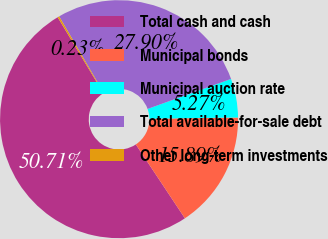Convert chart to OTSL. <chart><loc_0><loc_0><loc_500><loc_500><pie_chart><fcel>Total cash and cash<fcel>Municipal bonds<fcel>Municipal auction rate<fcel>Total available-for-sale debt<fcel>Other long-term investments<nl><fcel>50.7%<fcel>15.89%<fcel>5.27%<fcel>27.9%<fcel>0.23%<nl></chart> 